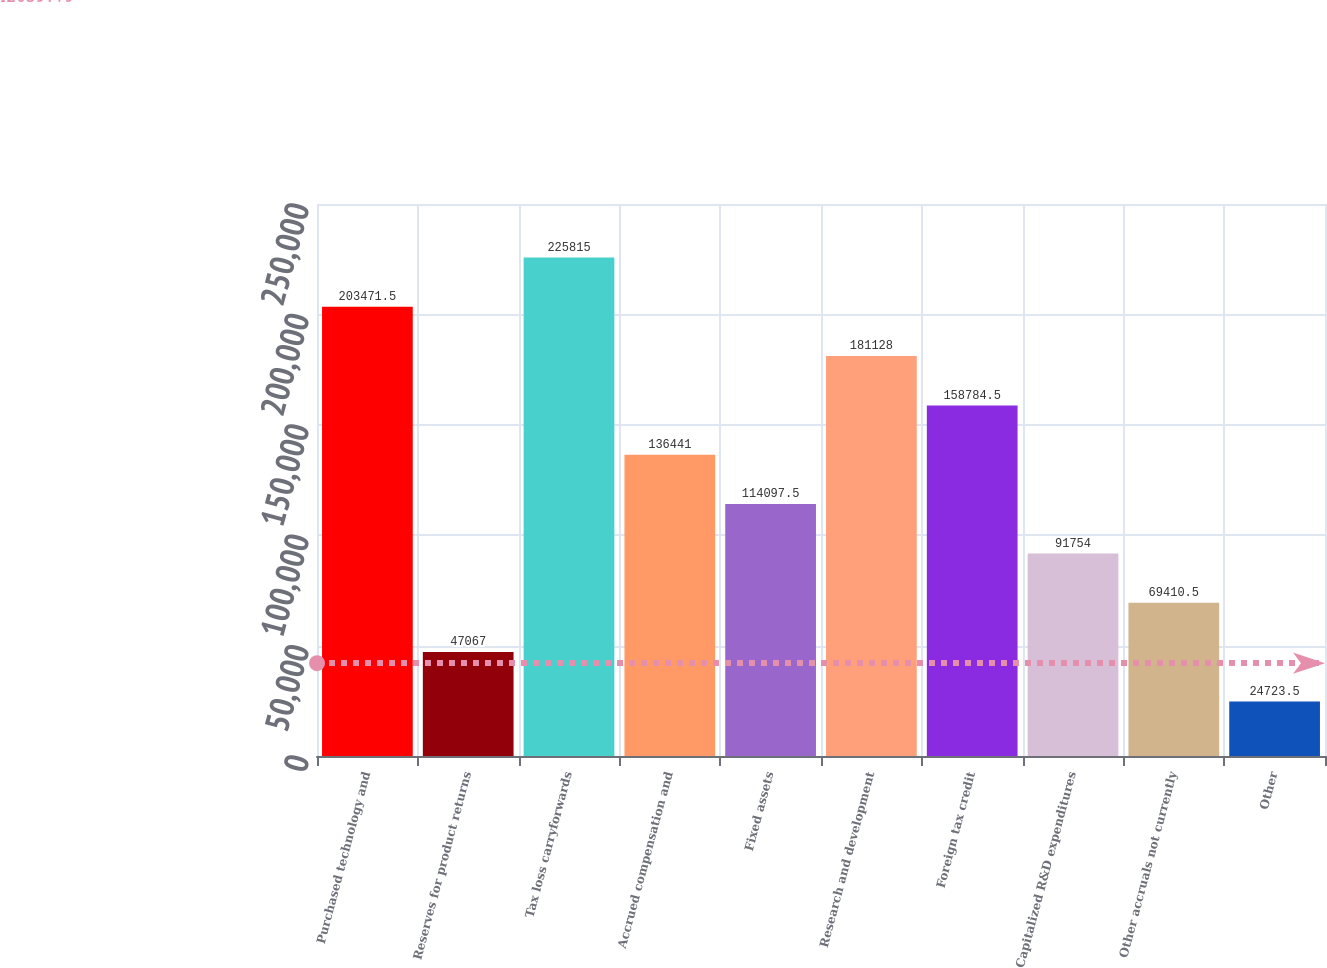<chart> <loc_0><loc_0><loc_500><loc_500><bar_chart><fcel>Purchased technology and<fcel>Reserves for product returns<fcel>Tax loss carryforwards<fcel>Accrued compensation and<fcel>Fixed assets<fcel>Research and development<fcel>Foreign tax credit<fcel>Capitalized R&D expenditures<fcel>Other accruals not currently<fcel>Other<nl><fcel>203472<fcel>47067<fcel>225815<fcel>136441<fcel>114098<fcel>181128<fcel>158784<fcel>91754<fcel>69410.5<fcel>24723.5<nl></chart> 